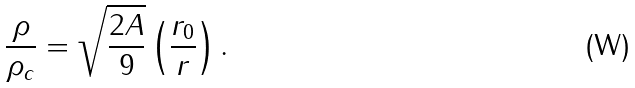<formula> <loc_0><loc_0><loc_500><loc_500>\frac { \rho } { \rho _ { c } } = \sqrt { \frac { 2 A } { 9 } } \left ( \frac { r _ { 0 } } { r } \right ) .</formula> 